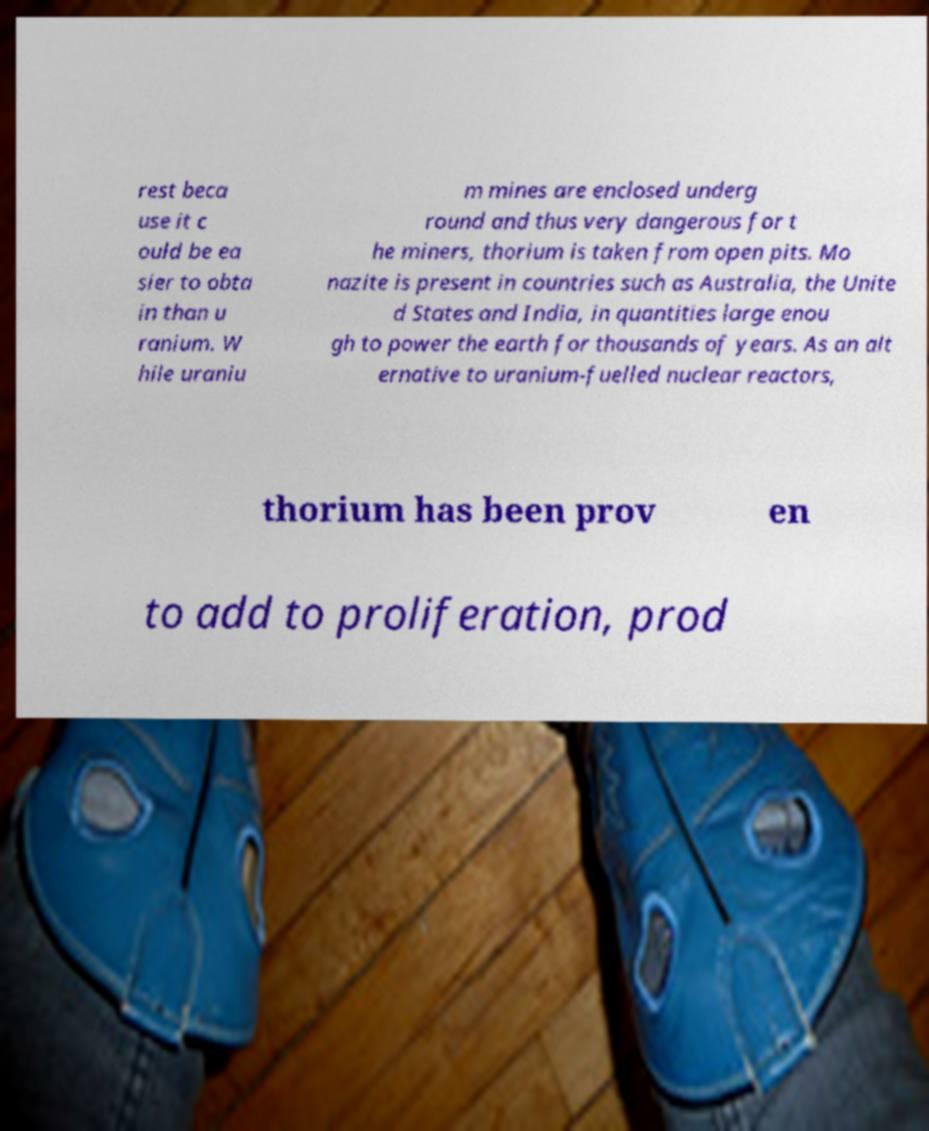For documentation purposes, I need the text within this image transcribed. Could you provide that? rest beca use it c ould be ea sier to obta in than u ranium. W hile uraniu m mines are enclosed underg round and thus very dangerous for t he miners, thorium is taken from open pits. Mo nazite is present in countries such as Australia, the Unite d States and India, in quantities large enou gh to power the earth for thousands of years. As an alt ernative to uranium-fuelled nuclear reactors, thorium has been prov en to add to proliferation, prod 